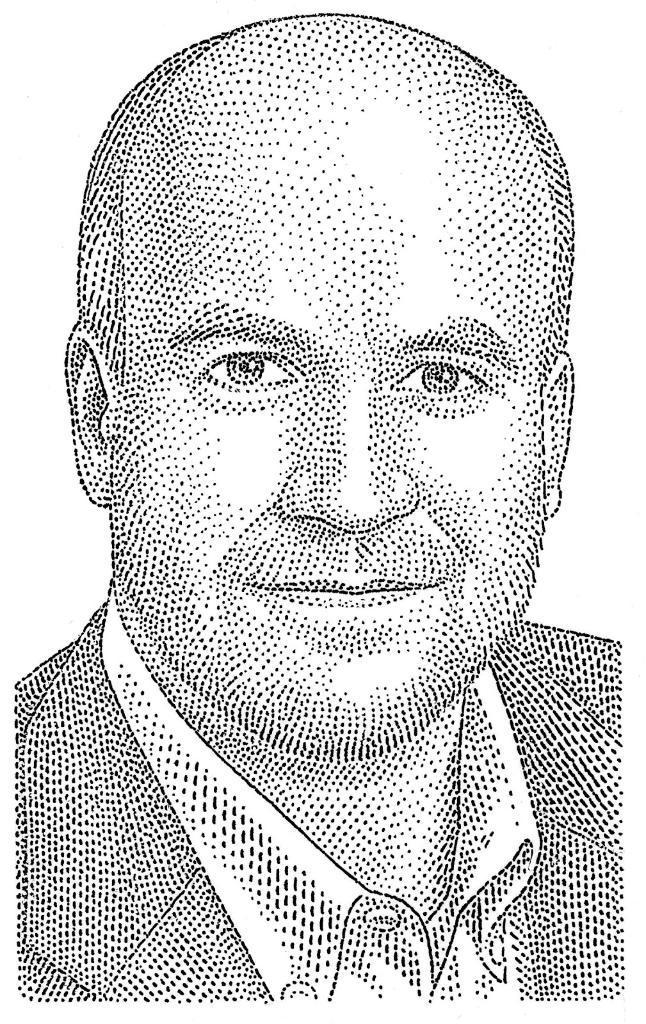In one or two sentences, can you explain what this image depicts? In this picture we observe a Dot portrait image of a man. 